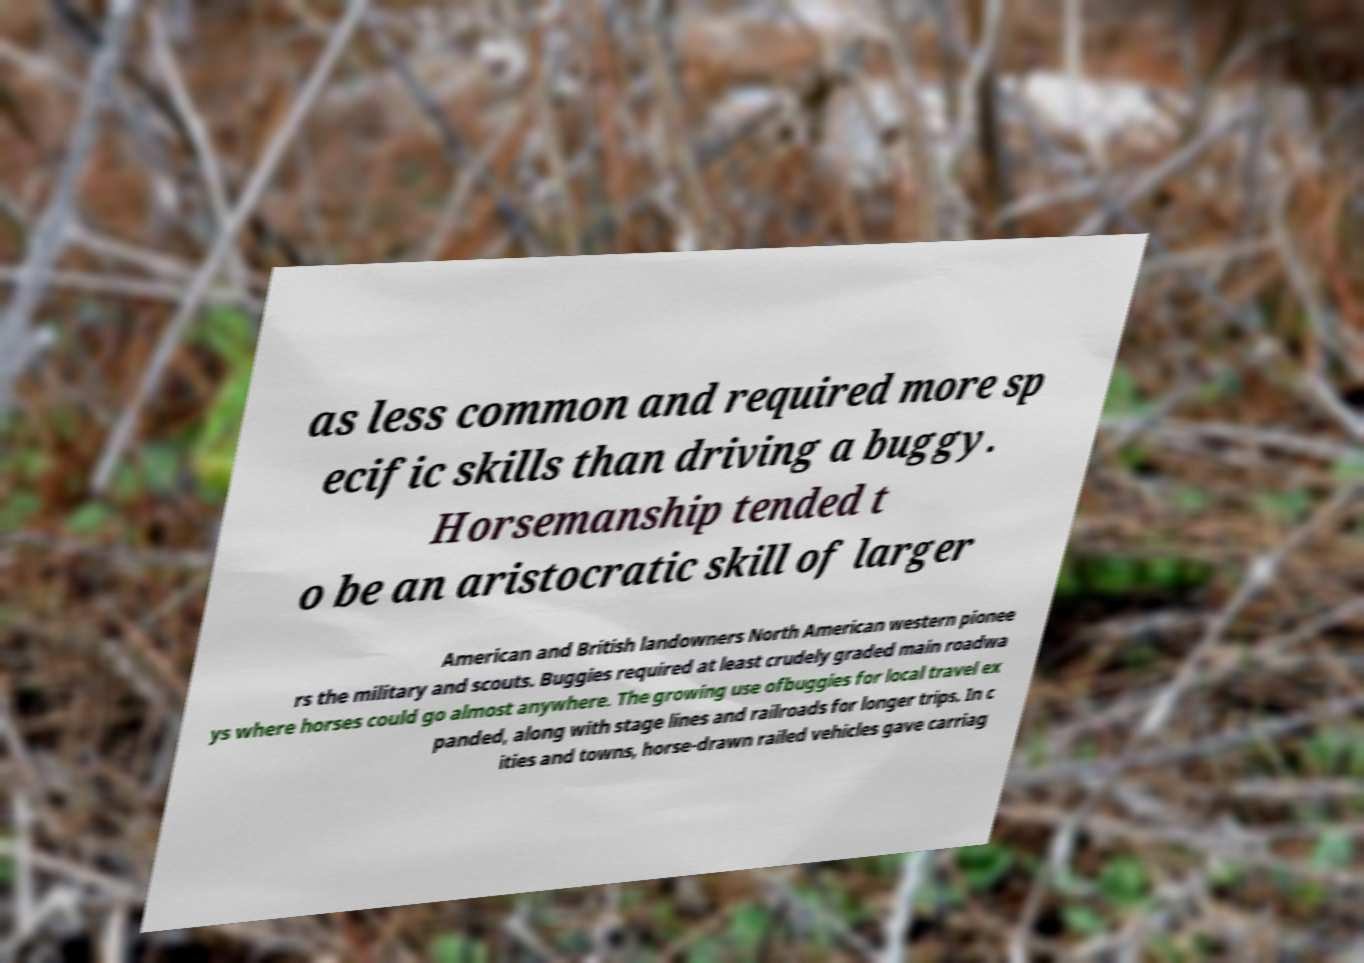Can you accurately transcribe the text from the provided image for me? as less common and required more sp ecific skills than driving a buggy. Horsemanship tended t o be an aristocratic skill of larger American and British landowners North American western pionee rs the military and scouts. Buggies required at least crudely graded main roadwa ys where horses could go almost anywhere. The growing use ofbuggies for local travel ex panded, along with stage lines and railroads for longer trips. In c ities and towns, horse-drawn railed vehicles gave carriag 